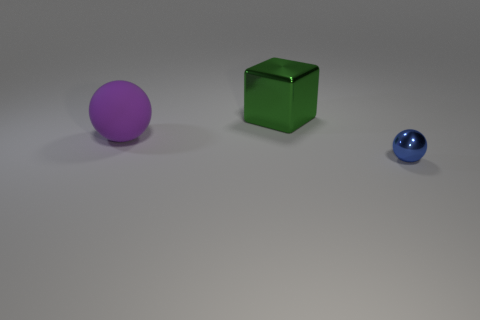There is a small object; is it the same shape as the big object that is in front of the green cube?
Keep it short and to the point. Yes. What color is the big object that is on the right side of the big thing in front of the shiny thing that is on the left side of the blue metal thing?
Your response must be concise. Green. Are there any other things that are the same material as the large cube?
Give a very brief answer. Yes. There is a thing that is in front of the big purple rubber object; does it have the same shape as the green shiny thing?
Make the answer very short. No. What is the large cube made of?
Your answer should be compact. Metal. There is a shiny object in front of the thing behind the object left of the large green thing; what is its shape?
Your response must be concise. Sphere. How many other objects are there of the same shape as the big green thing?
Your answer should be compact. 0. Does the tiny metallic sphere have the same color as the sphere to the left of the tiny blue shiny object?
Make the answer very short. No. How many small blue things are there?
Give a very brief answer. 1. What number of objects are gray matte cylinders or big green shiny things?
Make the answer very short. 1. 